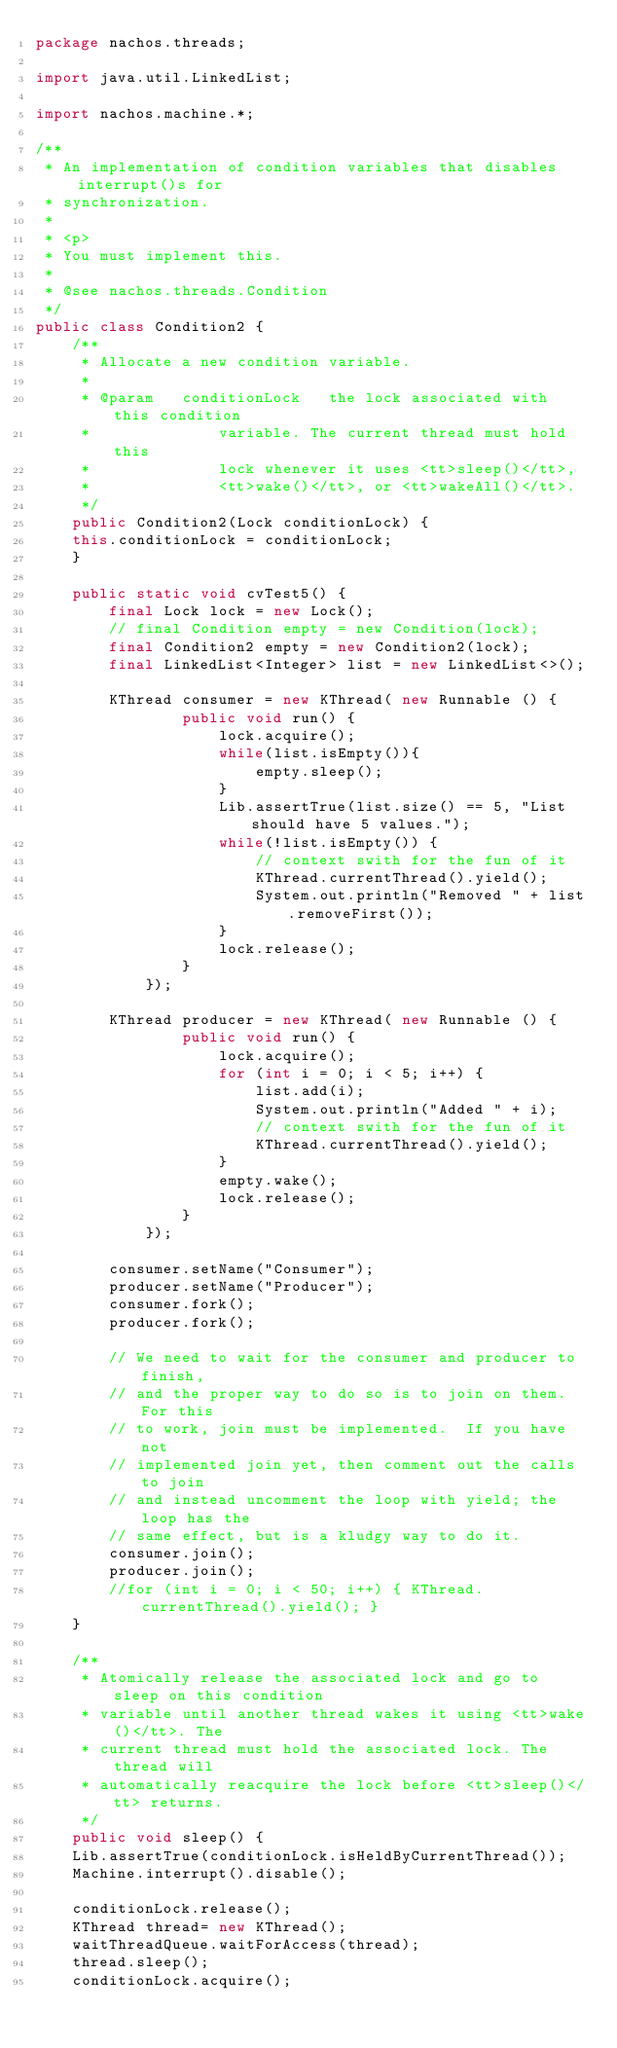Convert code to text. <code><loc_0><loc_0><loc_500><loc_500><_Java_>package nachos.threads;

import java.util.LinkedList;

import nachos.machine.*;

/**
 * An implementation of condition variables that disables interrupt()s for
 * synchronization.
 *
 * <p>
 * You must implement this.
 *
 * @see	nachos.threads.Condition
 */
public class Condition2 {
    /**
     * Allocate a new condition variable.
     *
     * @param	conditionLock	the lock associated with this condition
     *				variable. The current thread must hold this
     *				lock whenever it uses <tt>sleep()</tt>,
     *				<tt>wake()</tt>, or <tt>wakeAll()</tt>.
     */
    public Condition2(Lock conditionLock) {
	this.conditionLock = conditionLock;
    }
    
    public static void cvTest5() {
        final Lock lock = new Lock();
        // final Condition empty = new Condition(lock);
        final Condition2 empty = new Condition2(lock);
        final LinkedList<Integer> list = new LinkedList<>();

        KThread consumer = new KThread( new Runnable () {
                public void run() {
                    lock.acquire();
                    while(list.isEmpty()){
                        empty.sleep();
                    }
                    Lib.assertTrue(list.size() == 5, "List should have 5 values.");
                    while(!list.isEmpty()) {
                        // context swith for the fun of it
                        KThread.currentThread().yield();
                        System.out.println("Removed " + list.removeFirst());
                    }
                    lock.release();
                }
            });

        KThread producer = new KThread( new Runnable () {
                public void run() {
                    lock.acquire();
                    for (int i = 0; i < 5; i++) {
                        list.add(i);
                        System.out.println("Added " + i);
                        // context swith for the fun of it
                        KThread.currentThread().yield();
                    }
                    empty.wake();
                    lock.release();
                }
            });

        consumer.setName("Consumer");
        producer.setName("Producer");
        consumer.fork();
        producer.fork();

        // We need to wait for the consumer and producer to finish,
        // and the proper way to do so is to join on them.  For this
        // to work, join must be implemented.  If you have not
        // implemented join yet, then comment out the calls to join
        // and instead uncomment the loop with yield; the loop has the
        // same effect, but is a kludgy way to do it.
        consumer.join();
        producer.join();
        //for (int i = 0; i < 50; i++) { KThread.currentThread().yield(); }
    }

    /**
     * Atomically release the associated lock and go to sleep on this condition
     * variable until another thread wakes it using <tt>wake()</tt>. The
     * current thread must hold the associated lock. The thread will
     * automatically reacquire the lock before <tt>sleep()</tt> returns.
     */
    public void sleep() {
	Lib.assertTrue(conditionLock.isHeldByCurrentThread());
	Machine.interrupt().disable();

	conditionLock.release();
	KThread thread= new KThread();
	waitThreadQueue.waitForAccess(thread);
	thread.sleep();
	conditionLock.acquire();</code> 